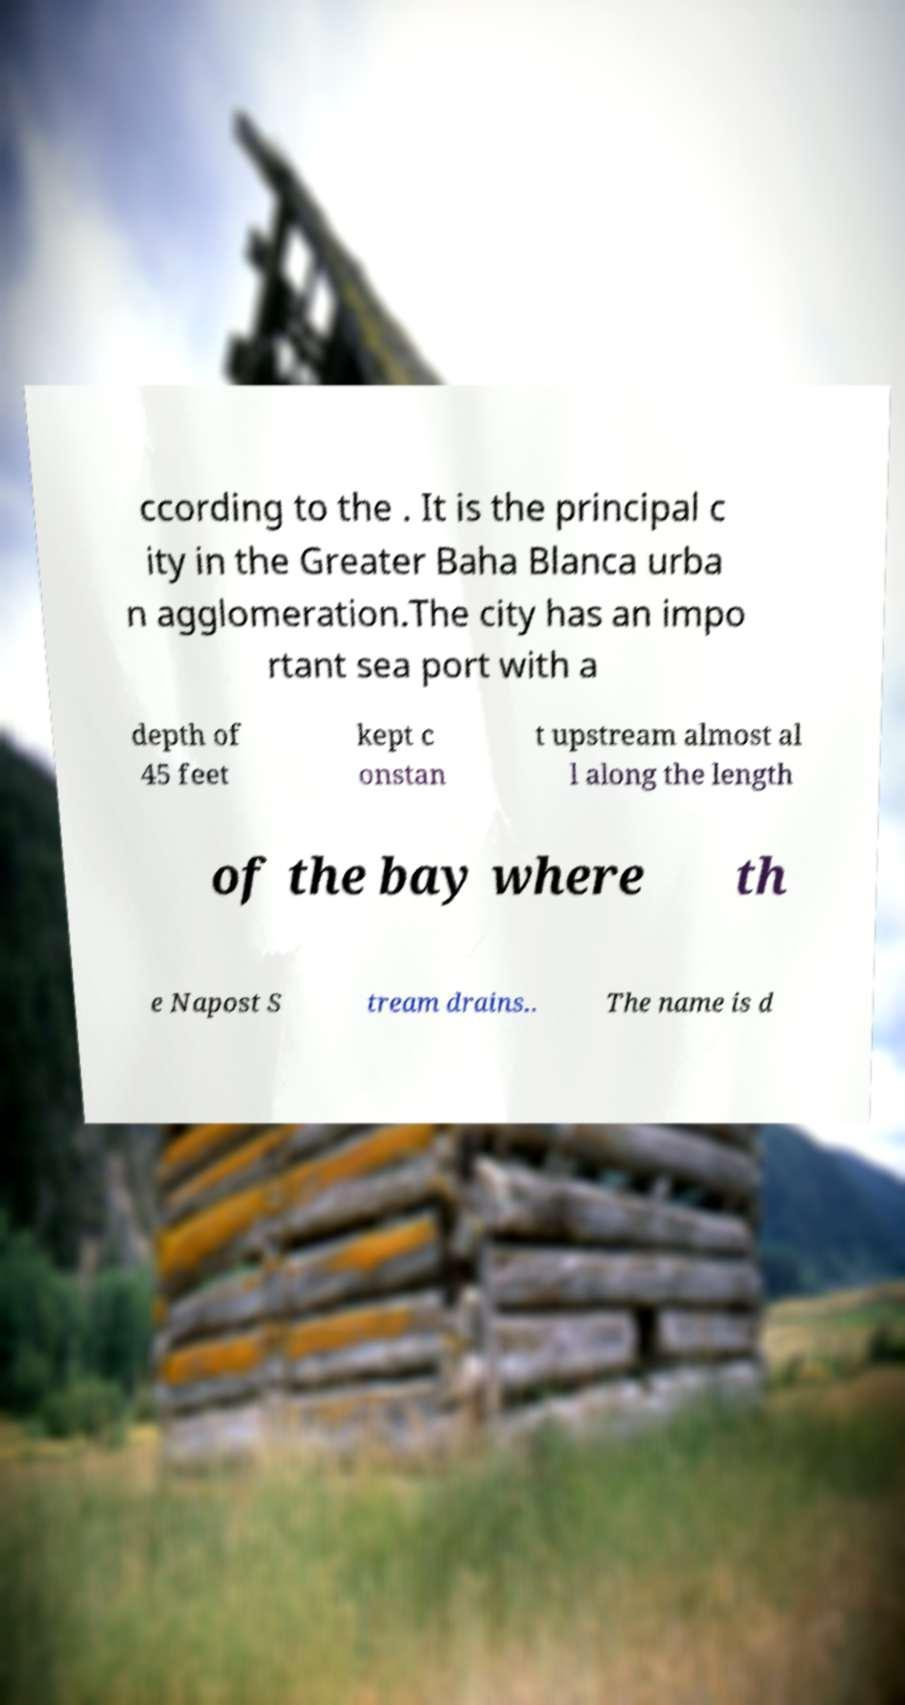What messages or text are displayed in this image? I need them in a readable, typed format. ccording to the . It is the principal c ity in the Greater Baha Blanca urba n agglomeration.The city has an impo rtant sea port with a depth of 45 feet kept c onstan t upstream almost al l along the length of the bay where th e Napost S tream drains.. The name is d 